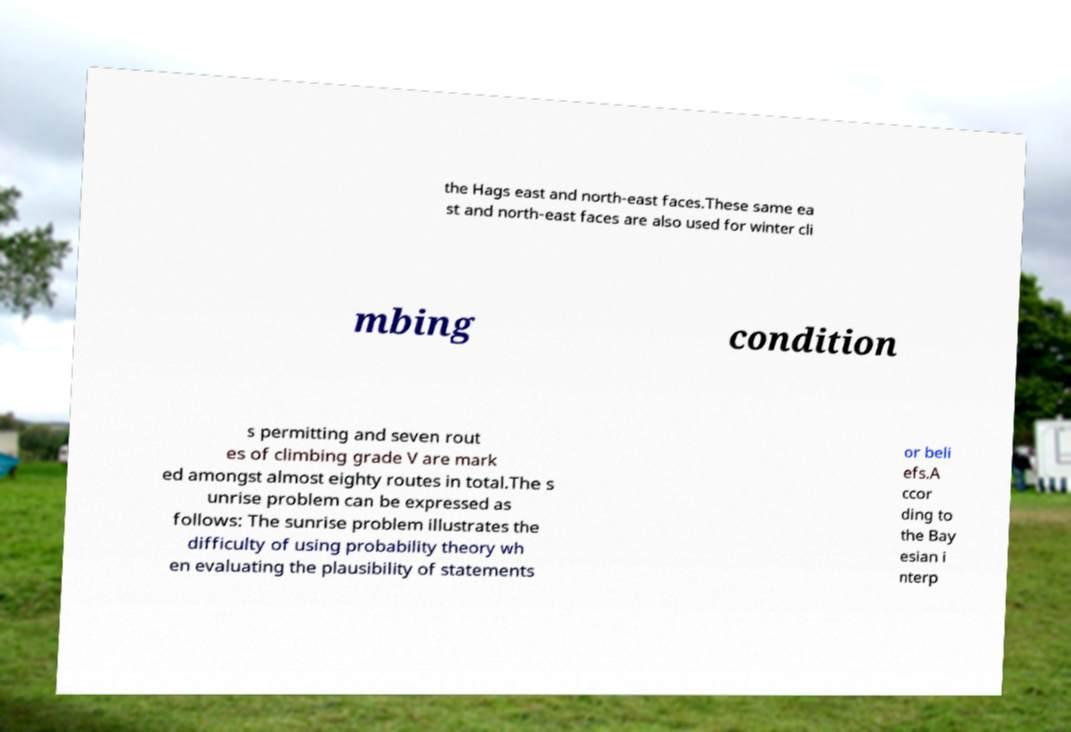Please read and relay the text visible in this image. What does it say? the Hags east and north-east faces.These same ea st and north-east faces are also used for winter cli mbing condition s permitting and seven rout es of climbing grade V are mark ed amongst almost eighty routes in total.The s unrise problem can be expressed as follows: The sunrise problem illustrates the difficulty of using probability theory wh en evaluating the plausibility of statements or beli efs.A ccor ding to the Bay esian i nterp 